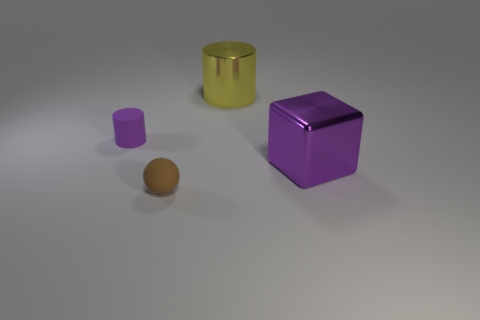Are there any rubber things that have the same size as the yellow metallic cylinder?
Make the answer very short. No. What is the size of the brown sphere?
Keep it short and to the point. Small. What number of yellow metal objects are the same size as the metallic cube?
Make the answer very short. 1. Is the number of purple matte cylinders behind the large purple thing less than the number of tiny rubber objects in front of the big cylinder?
Your answer should be very brief. Yes. How big is the thing that is to the right of the cylinder that is behind the purple object that is on the left side of the small brown rubber thing?
Keep it short and to the point. Large. What size is the object that is both behind the purple cube and to the right of the tiny purple matte cylinder?
Provide a short and direct response. Large. There is a matte object that is in front of the small object behind the large purple shiny block; what shape is it?
Offer a very short reply. Sphere. Is there anything else of the same color as the sphere?
Your response must be concise. No. There is a shiny object on the right side of the big yellow object; what shape is it?
Offer a very short reply. Cube. There is a thing that is both in front of the tiny matte cylinder and behind the tiny brown sphere; what shape is it?
Give a very brief answer. Cube. 